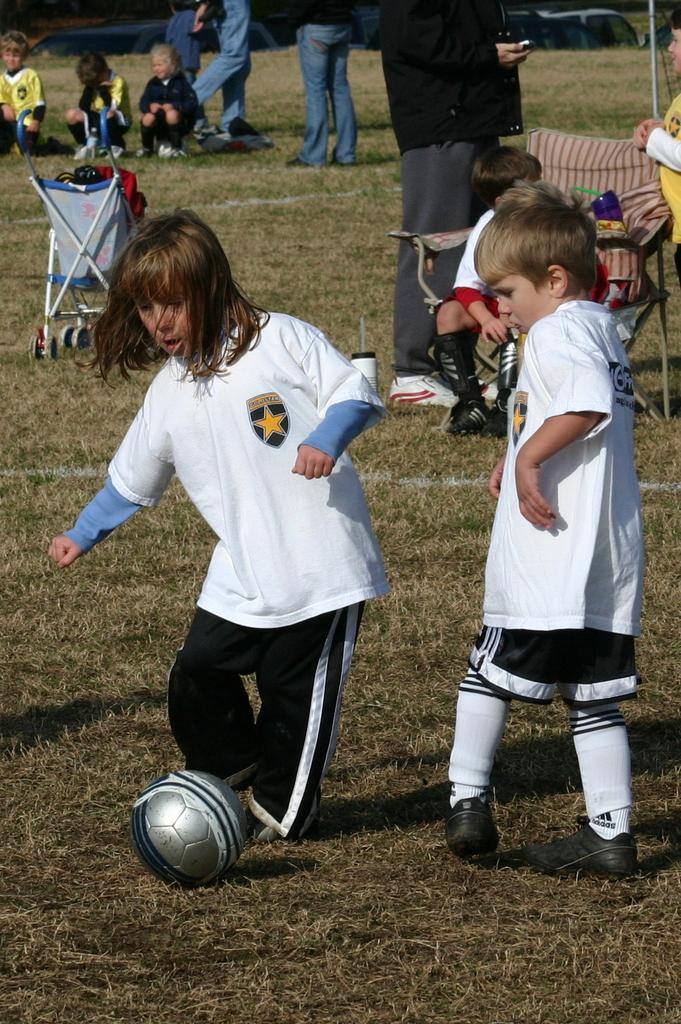What are the two children in the image doing? The two children are playing football in the image. What can be seen in the background of the image? There are many people in the background of the image. Where is the boy sitting in the image? The boy is sitting on a chair on the right side of the image. What type of mist is surrounding the children while they play football in the image? There is no mist present in the image; it is a clear day. 